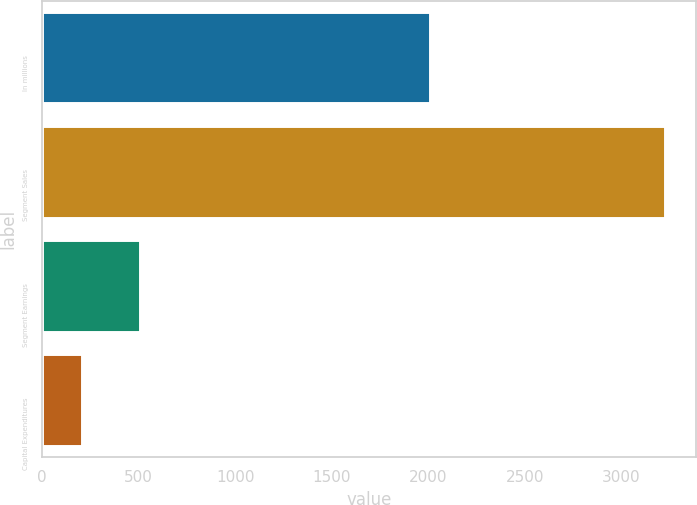Convert chart to OTSL. <chart><loc_0><loc_0><loc_500><loc_500><bar_chart><fcel>In millions<fcel>Segment Sales<fcel>Segment Earnings<fcel>Capital Expenditures<nl><fcel>2009<fcel>3225<fcel>507<fcel>205<nl></chart> 